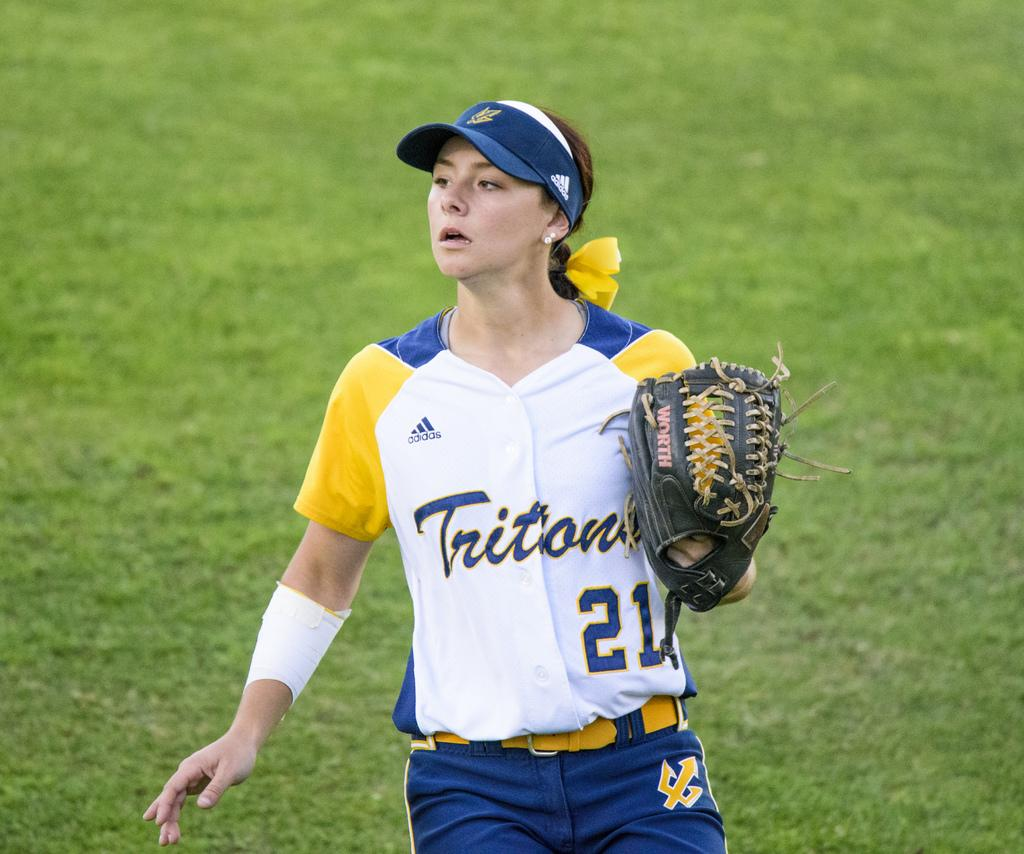Provide a one-sentence caption for the provided image. A player for the Tritons watches her teammate make the play. 